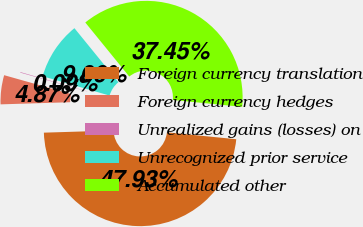Convert chart. <chart><loc_0><loc_0><loc_500><loc_500><pie_chart><fcel>Foreign currency translation<fcel>Foreign currency hedges<fcel>Unrealized gains (losses) on<fcel>Unrecognized prior service<fcel>Accumulated other<nl><fcel>47.93%<fcel>4.87%<fcel>0.09%<fcel>9.66%<fcel>37.45%<nl></chart> 